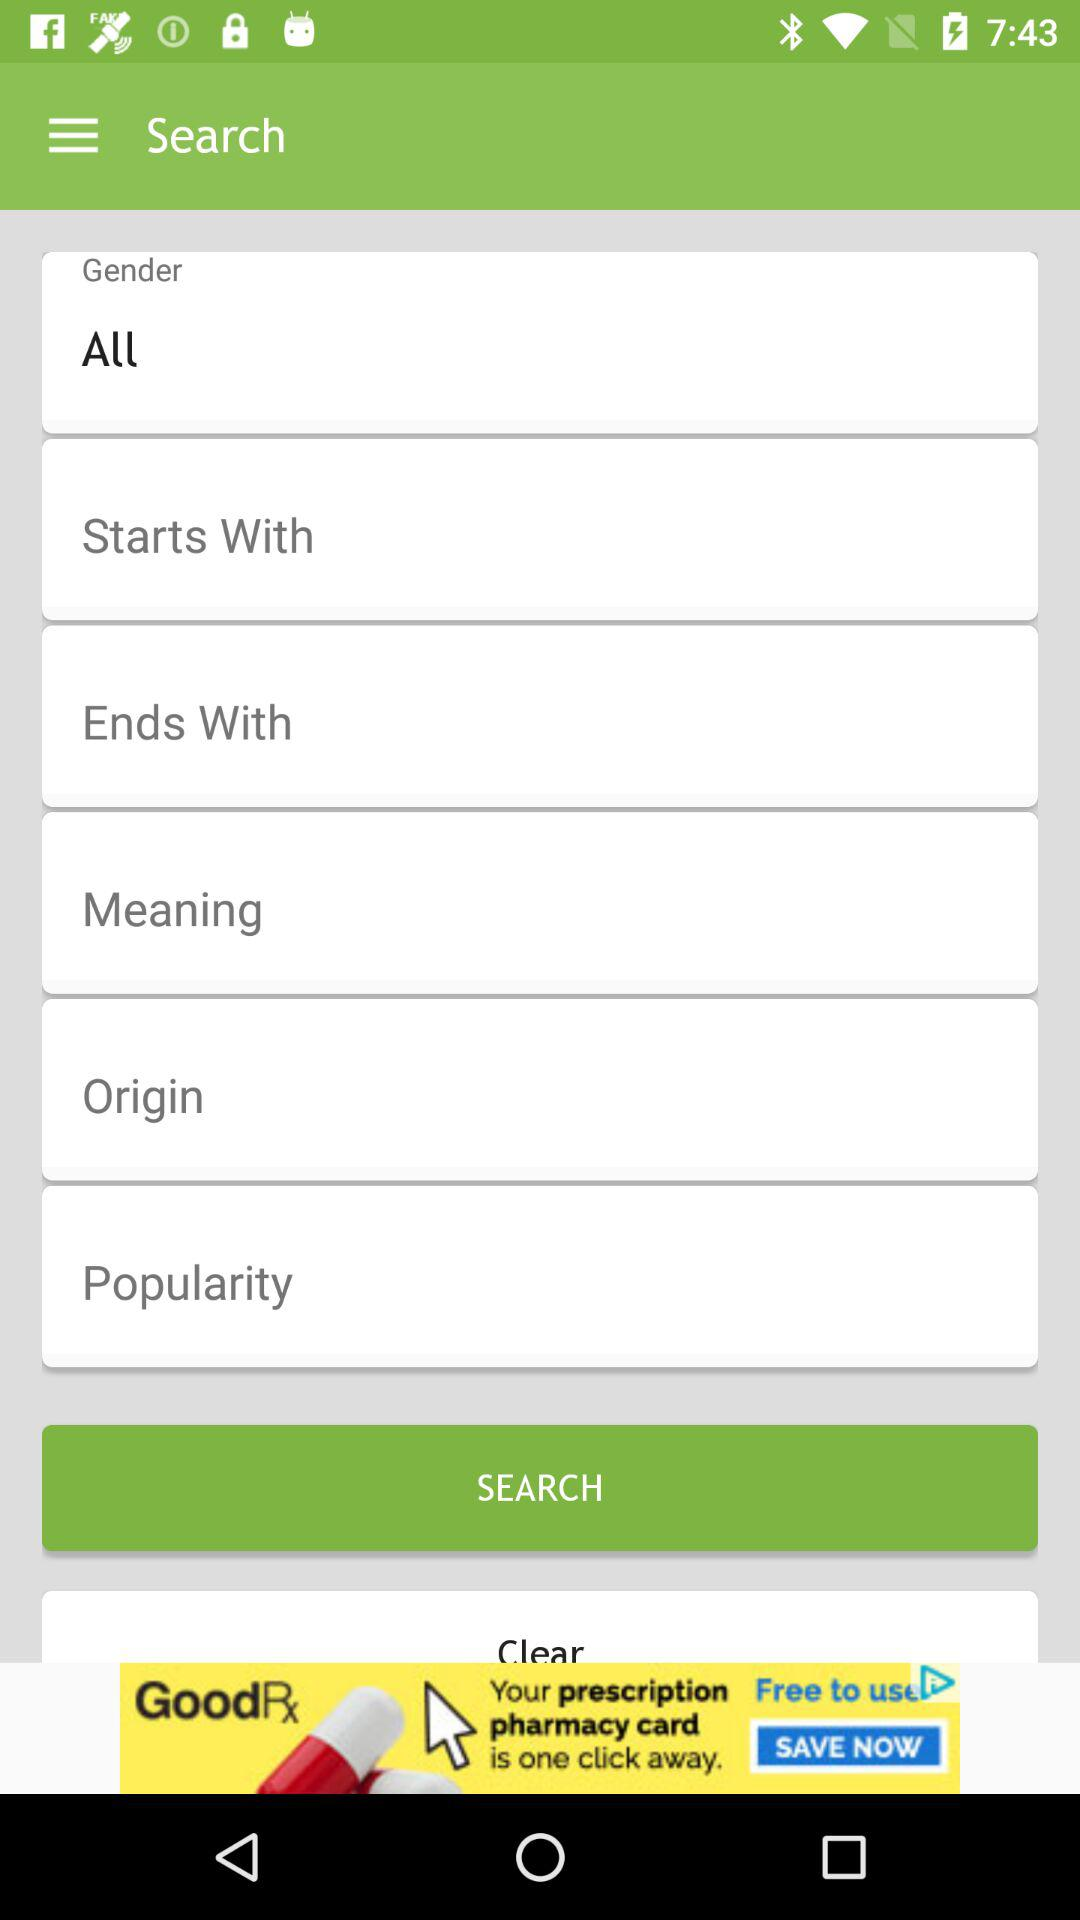Which origin is selected?
When the provided information is insufficient, respond with <no answer>. <no answer> 